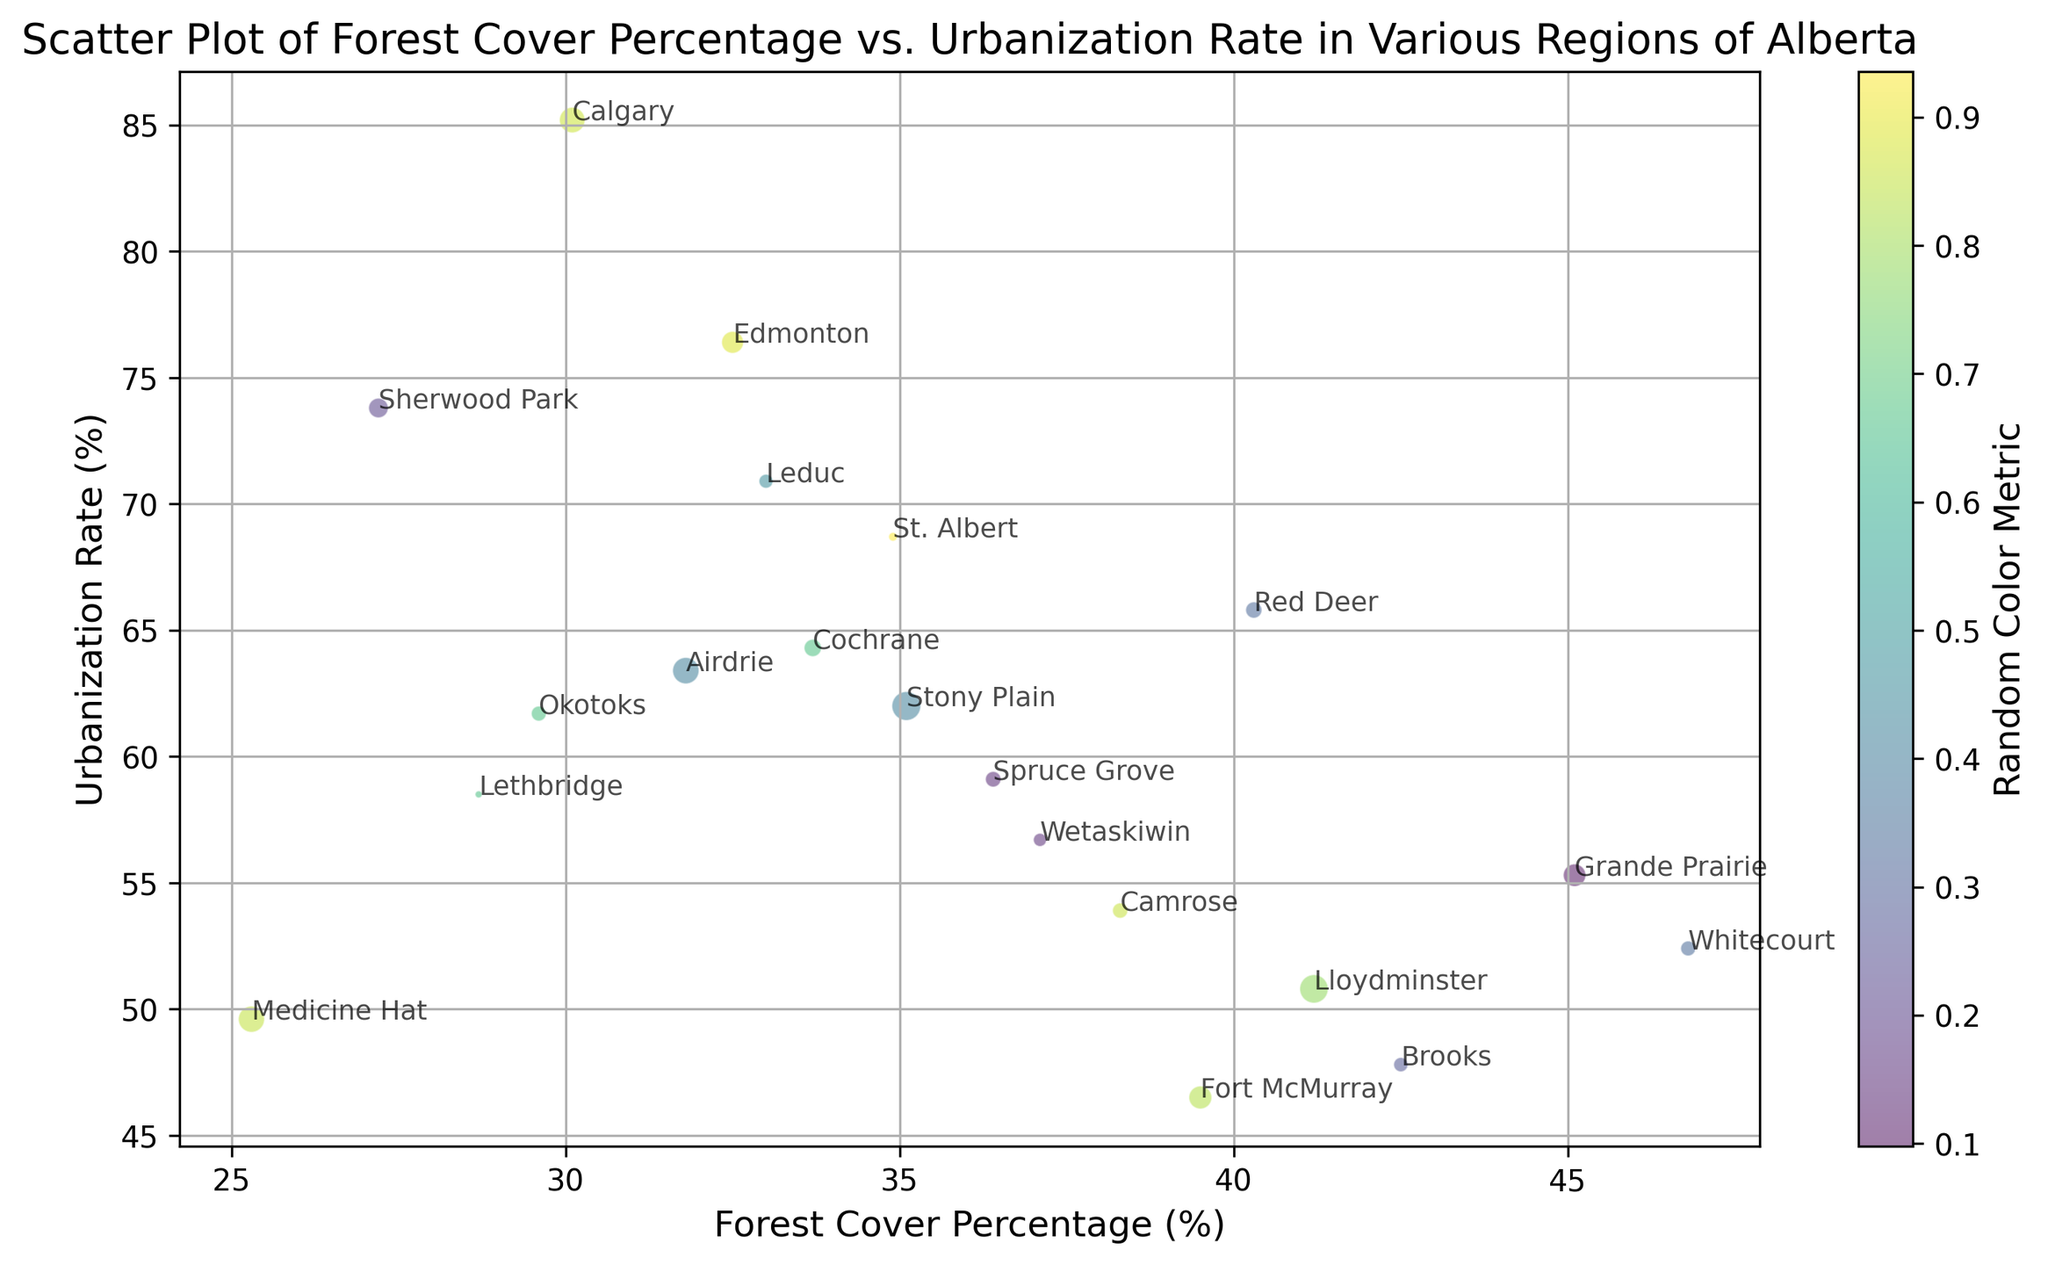What's the region with the highest forest cover percentage? Inspect the scatter plot and identify the data point with the highest position on the x-axis, then refer to the label for that point.
Answer: Whitecourt Compare the urbanization rates of Calgary and Edmonton. Which one is higher? Locate the points for Calgary and Edmonton on the scatter plot, then compare their y-axis positions; the higher position indicates a higher urbanization rate.
Answer: Calgary What is the average forest cover percentage for regions with an urbanization rate less than 60%? Identify the points where the y-axis value (urbanization rate) is less than 60%. Sum the x-axis values (forest cover percentage) for these points and divide by the number of such points. *Regions: Lethbridge, Medicine Hat, Grande Prairie, Fort McMurray, Lloydminster, Wetaskiwin, Whitecourt. Sum = 223.1, Count = 7*
Answer: 31.87% Which regions have a forest cover percentage greater than 40% and urbanization rate less than 60%? Look for points that meet both criteria by comparing the x-axis (forest cover percentage) and y-axis (urbanization rate).
Answer: Grande Prairie, Lloydminster, Wetaskiwin, Whitecourt Is there a visible trend between forest cover percentage and urbanization rate? Observe the overall distribution of points on the scatter plot to see if there is a discernible pattern or trend, such as an increasing or decreasing relationship.
Answer: No clear trend How many regions have both forest cover percentage and urbanization rate above 60%? Count the points where both x-axis (forest cover percentage) and y-axis (urbanization rate) values are above 60.
Answer: 4 Which region has the smallest size in the scatter plot, and what is its forest cover percentage? Identify the smallest data point on the scatter plot and refer to the label and the x-axis value for that point.
Answer: Medicine Hat, 25.3 What color metric range is represented by the color bar on the scatter plot? Examine the color bar included in the plot to understand the range labels (e.g., lowest value to highest value).
Answer: Random Color Metric Compare the forest cover percentage for Fort McMurray and Camrose and determine the difference. Locate the points for Fort McMurray and Camrose on the scatter plot and subtract the x-axis value of Camrose from that of Fort McMurray. Fort McMurray (39.5) - Camrose (38.3)
Answer: 1.2 Considering the colored markers, which region has the most distinct color from Edmonton? Identify Edmonton's point and compare the colors of other points in the plot, noting the most visually distinct color.
Answer: Subjective depending on visual interpretation 